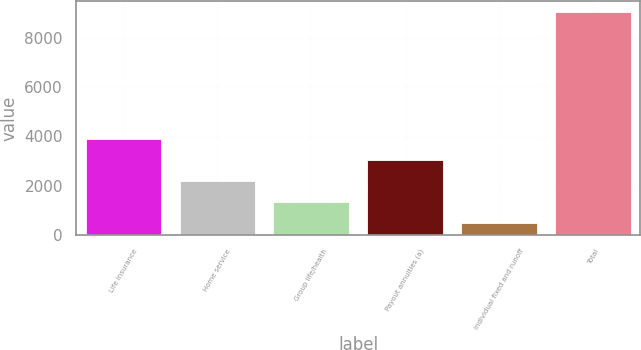Convert chart. <chart><loc_0><loc_0><loc_500><loc_500><bar_chart><fcel>Life insurance<fcel>Home service<fcel>Group life/health<fcel>Payout annuities (a)<fcel>Individual fixed and runoff<fcel>Total<nl><fcel>3907<fcel>2200<fcel>1346.5<fcel>3053.5<fcel>493<fcel>9028<nl></chart> 